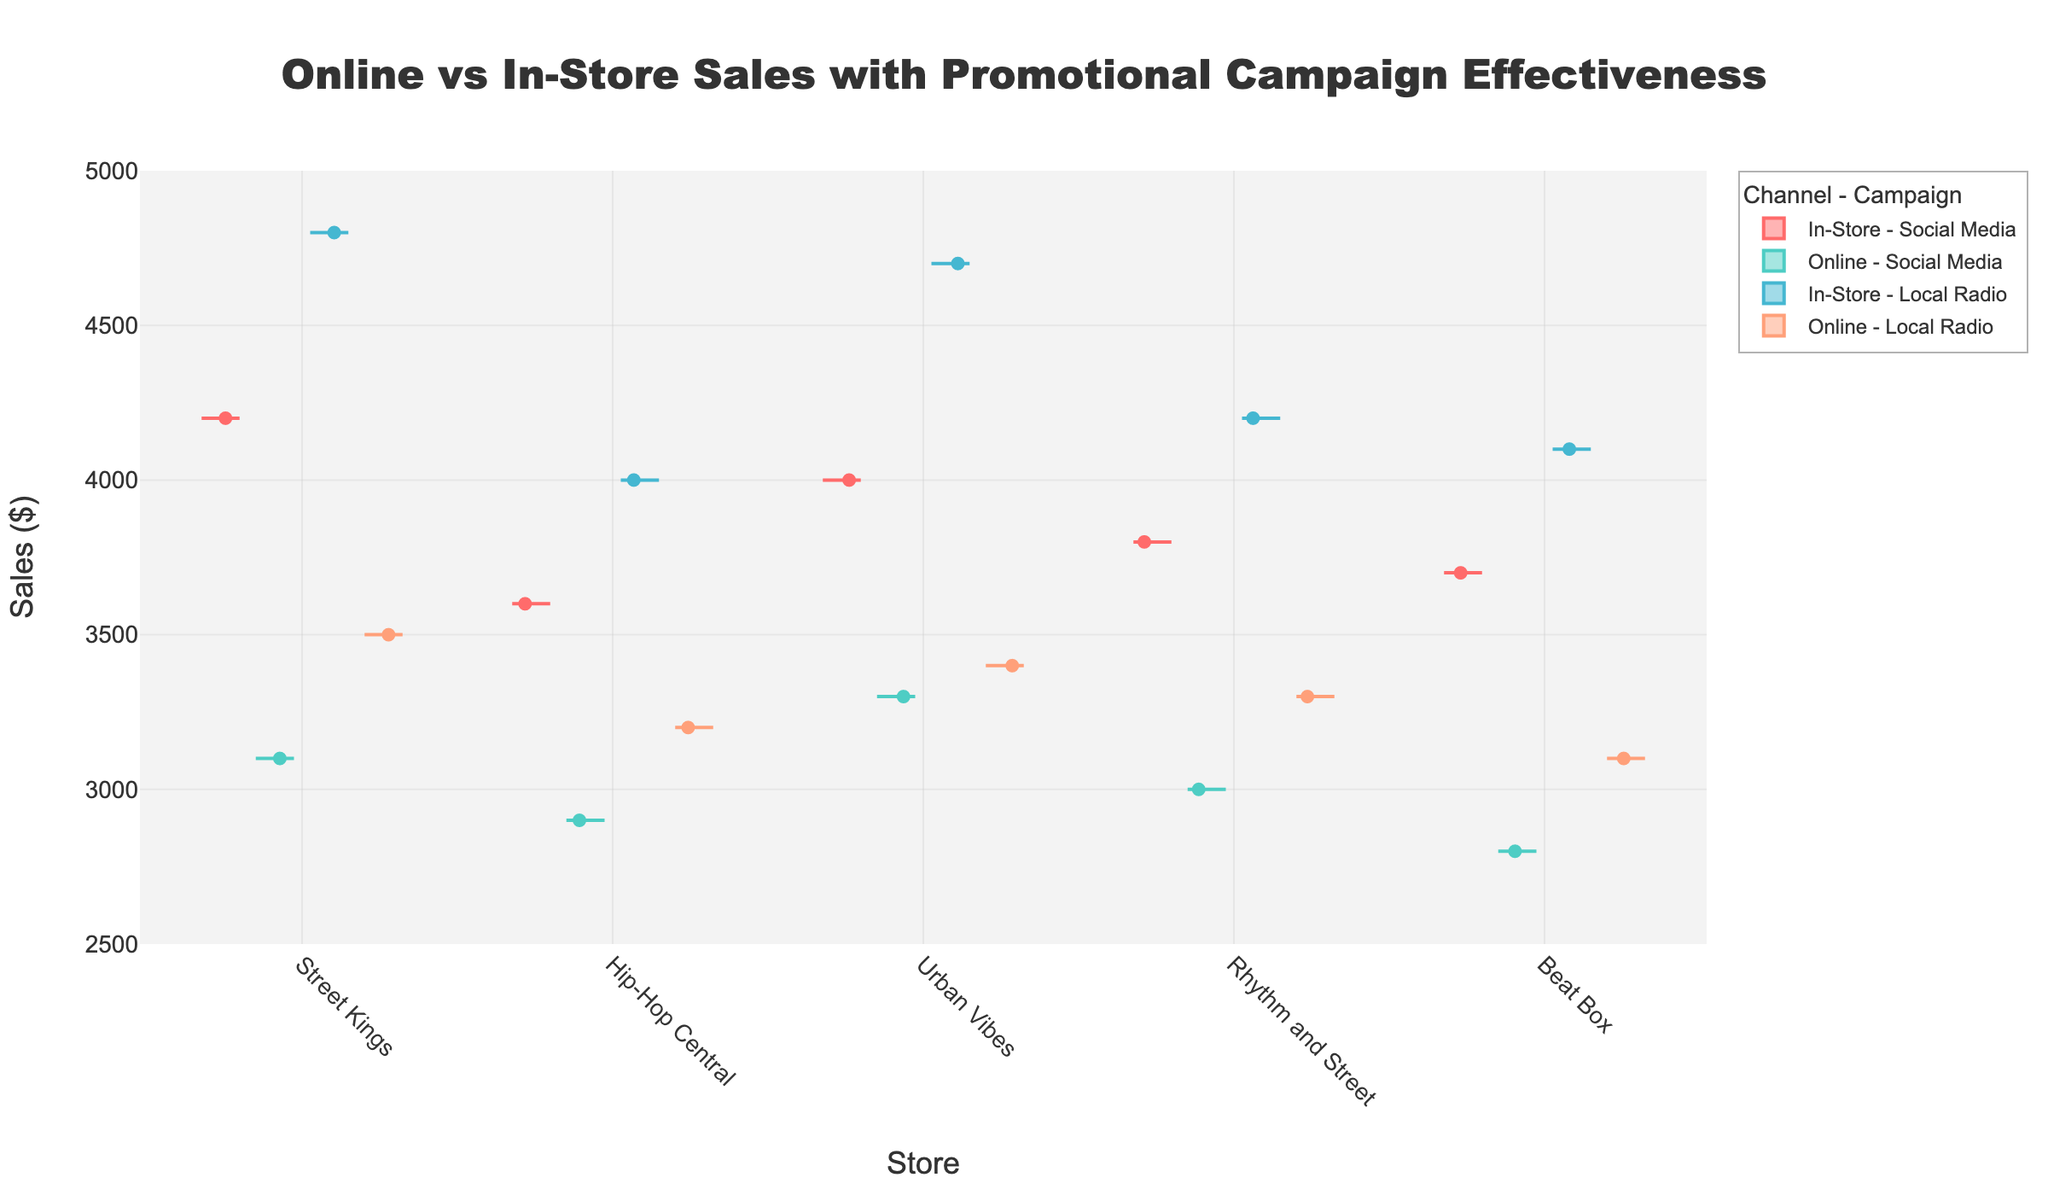Which promotional campaign generates higher sales for in-store purchases at Street Kings? Compare the in-store sales data for Street Kings under the 'Social Media' and 'Local Radio' campaigns. The sales for 'Social Media' are 4200, and for 'Local Radio' are 4800.
Answer: Local Radio How do in-store and online sales compare at Hip-Hop Central when using the Social Media campaign? Compare the sales values for Hip-Hop Central under the 'Social Media' campaign for both channels. In-store sales are 3600, while online sales are 2900.
Answer: In-store sales are higher What is the range of sales for Urban Vibes using the Local Radio campaign, combining both channels? The sales values for Urban Vibes under the 'Local Radio' campaign are 4700 (In-Store) and 3400 (Online). The range is calculated as the difference between the highest and lowest values. (4700 - 3400)
Answer: 1300 Across all stores, which promotional channel – Social Media or Local Radio – results in generally higher online sales? Compare the online sales data for the 'Social Media' and 'Local Radio' campaigns across all stores. The 'Social Media' online sales are generally 3100, 2900, 3300, 3000, and 2800, whereas 'Local Radio' online sales are 3500, 3200, 3400, 3300, and 3100.
Answer: Local Radio Which store shows the highest in-store sales when using Social Media as the promotional campaign? Evaluate the in-store sales under the 'Social Media' campaign for each store. Urban Vibes has the highest sales value at 4000.
Answer: Urban Vibes What is the median online sales value for Beat Box across both promotional campaigns? Find the online sales values for Beat Box, which are 2800 (Social Media) and 3100 (Local Radio). The median is the middle value of these sorted numbers.
Answer: 2950 Is the variability in in-store sales higher with Local Radio or Social Media campaign for Rhythm and Street? Compare the spread (range) of in-store sales for Rhythm and Street under both campaigns. For 'Local Radio', the value is 4200, for 'Social Media' is 3800. The variability can be inferred from these numbers.
Answer: Social Media (given wider range among stores) Which store has the lowest online sales with the Social Media campaign? Review the online sales values under the 'Social Media' campaign. Beat Box has the lowest saales of 2800.
Answer: Beat Box 